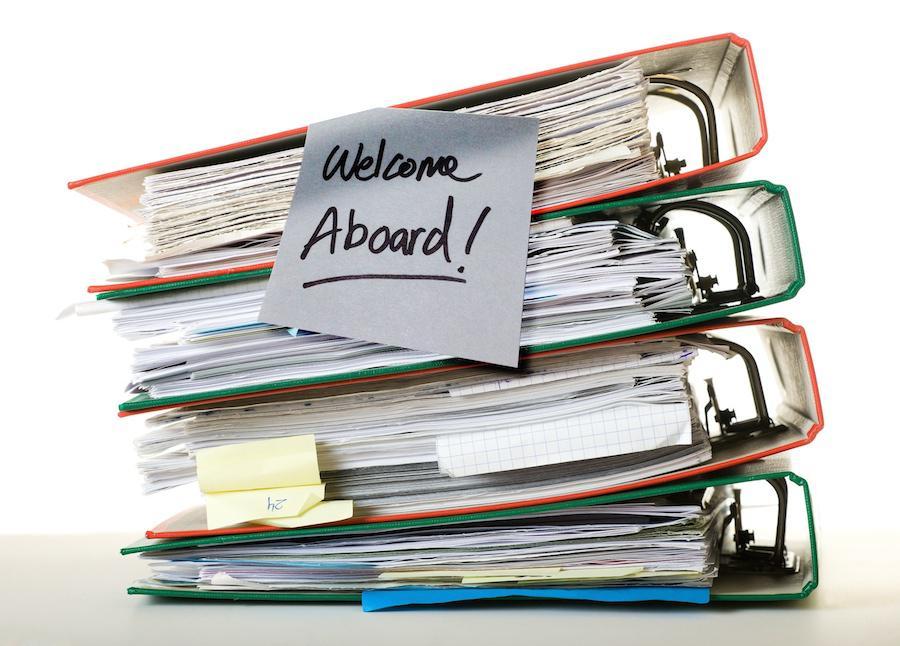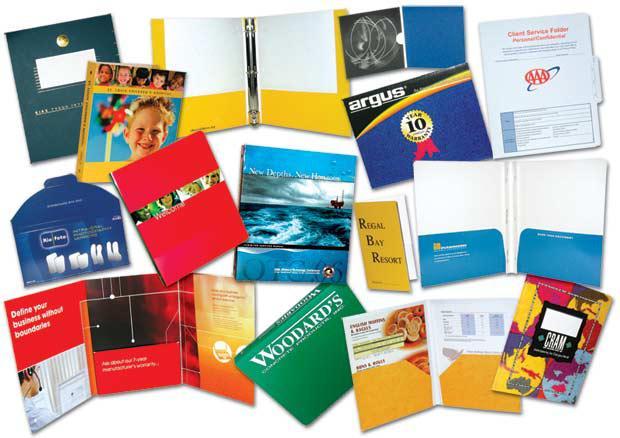The first image is the image on the left, the second image is the image on the right. For the images shown, is this caption "Right image shows multiple different solid colored binders of the same size." true? Answer yes or no. No. The first image is the image on the left, the second image is the image on the right. Considering the images on both sides, is "In one image, bright colored binders have large white labels on the narrow closed end." valid? Answer yes or no. No. 